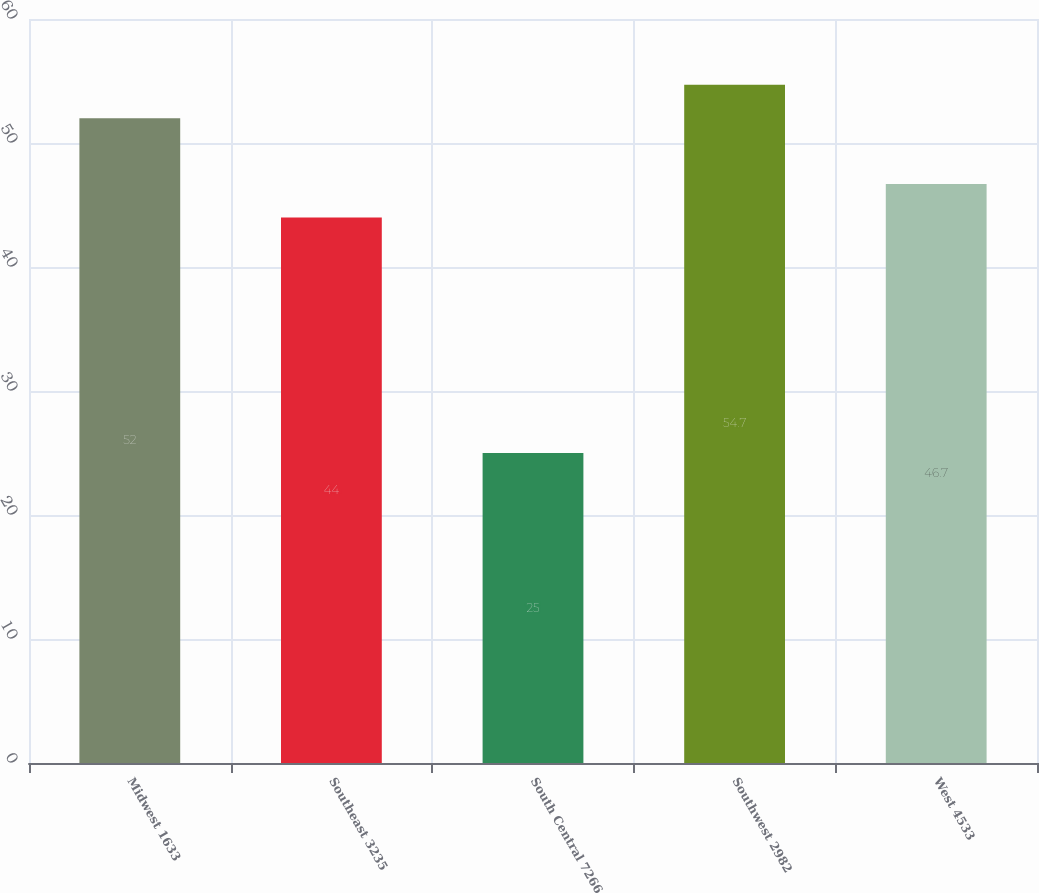Convert chart. <chart><loc_0><loc_0><loc_500><loc_500><bar_chart><fcel>Midwest 1633<fcel>Southeast 3235<fcel>South Central 7266<fcel>Southwest 2982<fcel>West 4533<nl><fcel>52<fcel>44<fcel>25<fcel>54.7<fcel>46.7<nl></chart> 